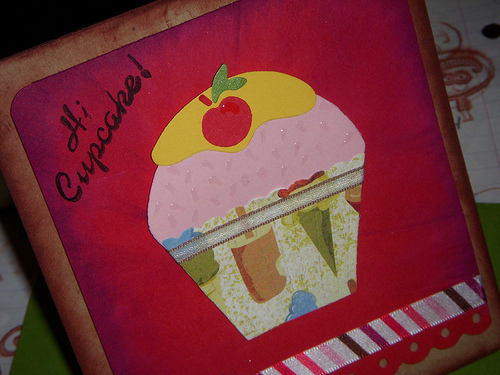<image>
Is the cherry on the frosting? Yes. Looking at the image, I can see the cherry is positioned on top of the frosting, with the frosting providing support. 